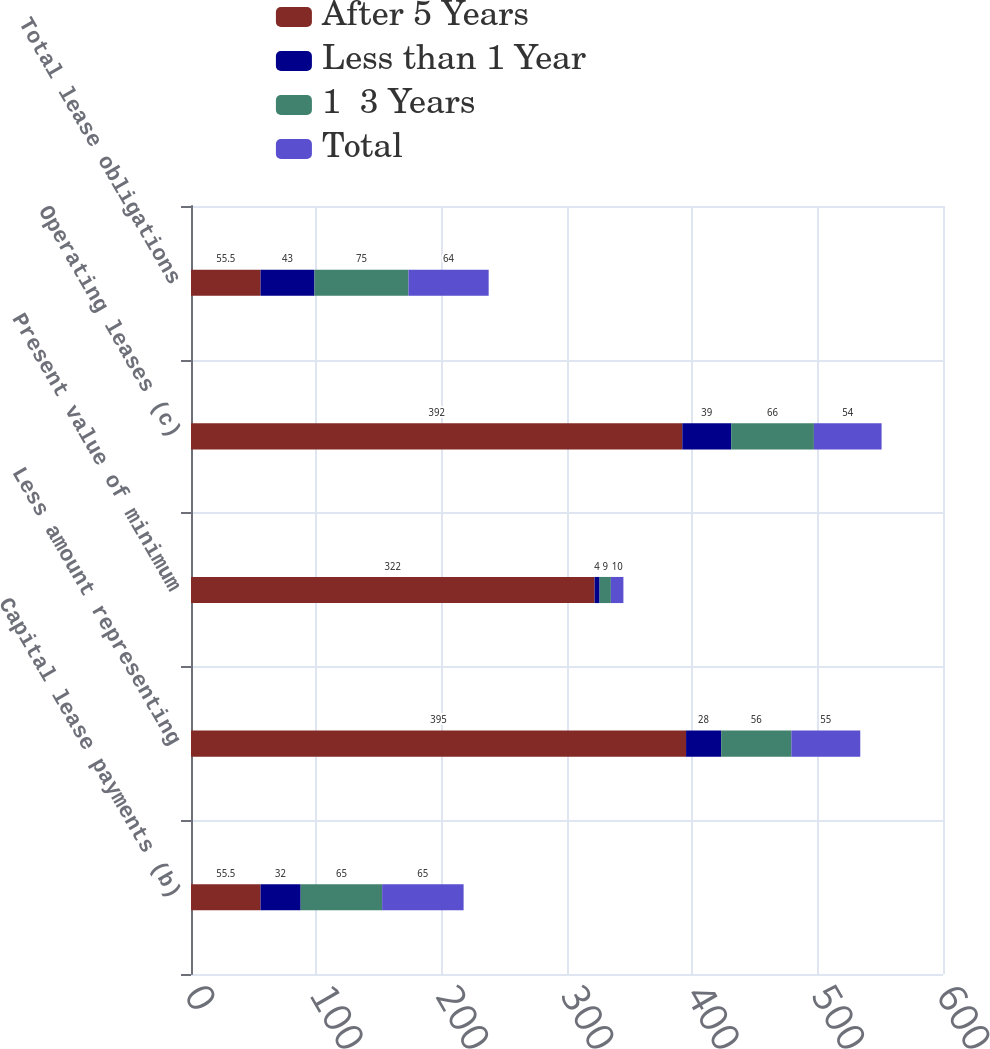Convert chart. <chart><loc_0><loc_0><loc_500><loc_500><stacked_bar_chart><ecel><fcel>Capital lease payments (b)<fcel>Less amount representing<fcel>Present value of minimum<fcel>Operating leases (c)<fcel>Total lease obligations<nl><fcel>After 5 Years<fcel>55.5<fcel>395<fcel>322<fcel>392<fcel>55.5<nl><fcel>Less than 1 Year<fcel>32<fcel>28<fcel>4<fcel>39<fcel>43<nl><fcel>1  3 Years<fcel>65<fcel>56<fcel>9<fcel>66<fcel>75<nl><fcel>Total<fcel>65<fcel>55<fcel>10<fcel>54<fcel>64<nl></chart> 